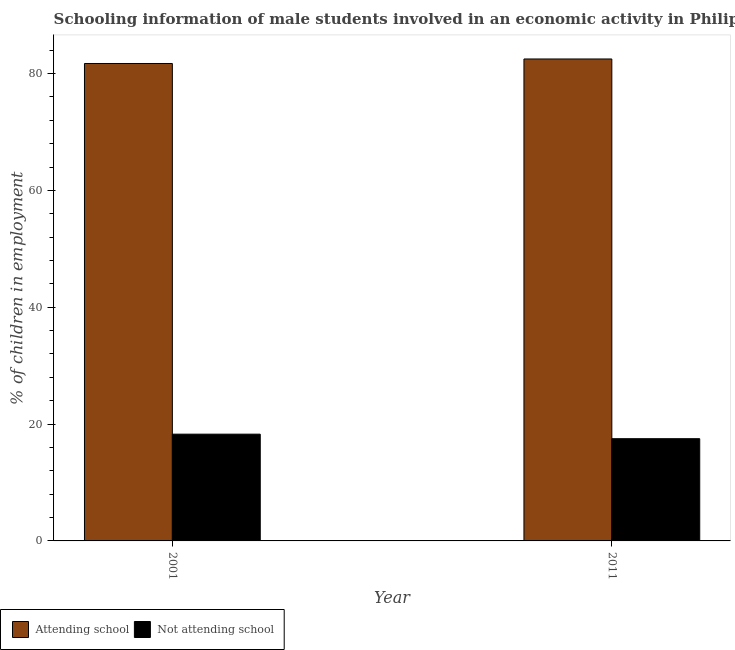How many bars are there on the 1st tick from the left?
Make the answer very short. 2. How many bars are there on the 2nd tick from the right?
Your answer should be very brief. 2. What is the label of the 2nd group of bars from the left?
Provide a short and direct response. 2011. What is the percentage of employed males who are attending school in 2011?
Keep it short and to the point. 82.5. Across all years, what is the maximum percentage of employed males who are not attending school?
Give a very brief answer. 18.27. Across all years, what is the minimum percentage of employed males who are attending school?
Your response must be concise. 81.73. What is the total percentage of employed males who are not attending school in the graph?
Your answer should be compact. 35.77. What is the difference between the percentage of employed males who are attending school in 2001 and that in 2011?
Ensure brevity in your answer.  -0.77. What is the difference between the percentage of employed males who are not attending school in 2011 and the percentage of employed males who are attending school in 2001?
Your answer should be compact. -0.77. What is the average percentage of employed males who are attending school per year?
Your response must be concise. 82.11. In how many years, is the percentage of employed males who are not attending school greater than 80 %?
Ensure brevity in your answer.  0. What is the ratio of the percentage of employed males who are attending school in 2001 to that in 2011?
Offer a terse response. 0.99. Is the percentage of employed males who are not attending school in 2001 less than that in 2011?
Your response must be concise. No. In how many years, is the percentage of employed males who are not attending school greater than the average percentage of employed males who are not attending school taken over all years?
Offer a terse response. 1. What does the 1st bar from the left in 2011 represents?
Offer a terse response. Attending school. What does the 1st bar from the right in 2001 represents?
Offer a terse response. Not attending school. How many bars are there?
Provide a succinct answer. 4. Are all the bars in the graph horizontal?
Your answer should be very brief. No. What is the difference between two consecutive major ticks on the Y-axis?
Offer a terse response. 20. Are the values on the major ticks of Y-axis written in scientific E-notation?
Keep it short and to the point. No. Does the graph contain any zero values?
Make the answer very short. No. How many legend labels are there?
Offer a terse response. 2. How are the legend labels stacked?
Make the answer very short. Horizontal. What is the title of the graph?
Ensure brevity in your answer.  Schooling information of male students involved in an economic activity in Philippines. Does "International Tourists" appear as one of the legend labels in the graph?
Make the answer very short. No. What is the label or title of the Y-axis?
Give a very brief answer. % of children in employment. What is the % of children in employment of Attending school in 2001?
Your response must be concise. 81.73. What is the % of children in employment of Not attending school in 2001?
Offer a very short reply. 18.27. What is the % of children in employment of Attending school in 2011?
Offer a very short reply. 82.5. What is the % of children in employment in Not attending school in 2011?
Provide a short and direct response. 17.5. Across all years, what is the maximum % of children in employment in Attending school?
Your answer should be very brief. 82.5. Across all years, what is the maximum % of children in employment of Not attending school?
Keep it short and to the point. 18.27. Across all years, what is the minimum % of children in employment of Attending school?
Your response must be concise. 81.73. Across all years, what is the minimum % of children in employment of Not attending school?
Provide a succinct answer. 17.5. What is the total % of children in employment in Attending school in the graph?
Your answer should be very brief. 164.23. What is the total % of children in employment in Not attending school in the graph?
Your answer should be very brief. 35.77. What is the difference between the % of children in employment in Attending school in 2001 and that in 2011?
Provide a succinct answer. -0.77. What is the difference between the % of children in employment of Not attending school in 2001 and that in 2011?
Provide a succinct answer. 0.77. What is the difference between the % of children in employment of Attending school in 2001 and the % of children in employment of Not attending school in 2011?
Give a very brief answer. 64.23. What is the average % of children in employment in Attending school per year?
Provide a succinct answer. 82.11. What is the average % of children in employment in Not attending school per year?
Ensure brevity in your answer.  17.89. In the year 2001, what is the difference between the % of children in employment of Attending school and % of children in employment of Not attending school?
Ensure brevity in your answer.  63.45. What is the ratio of the % of children in employment in Attending school in 2001 to that in 2011?
Give a very brief answer. 0.99. What is the ratio of the % of children in employment in Not attending school in 2001 to that in 2011?
Offer a terse response. 1.04. What is the difference between the highest and the second highest % of children in employment of Attending school?
Make the answer very short. 0.77. What is the difference between the highest and the second highest % of children in employment in Not attending school?
Your answer should be compact. 0.77. What is the difference between the highest and the lowest % of children in employment in Attending school?
Offer a very short reply. 0.77. What is the difference between the highest and the lowest % of children in employment of Not attending school?
Provide a short and direct response. 0.77. 